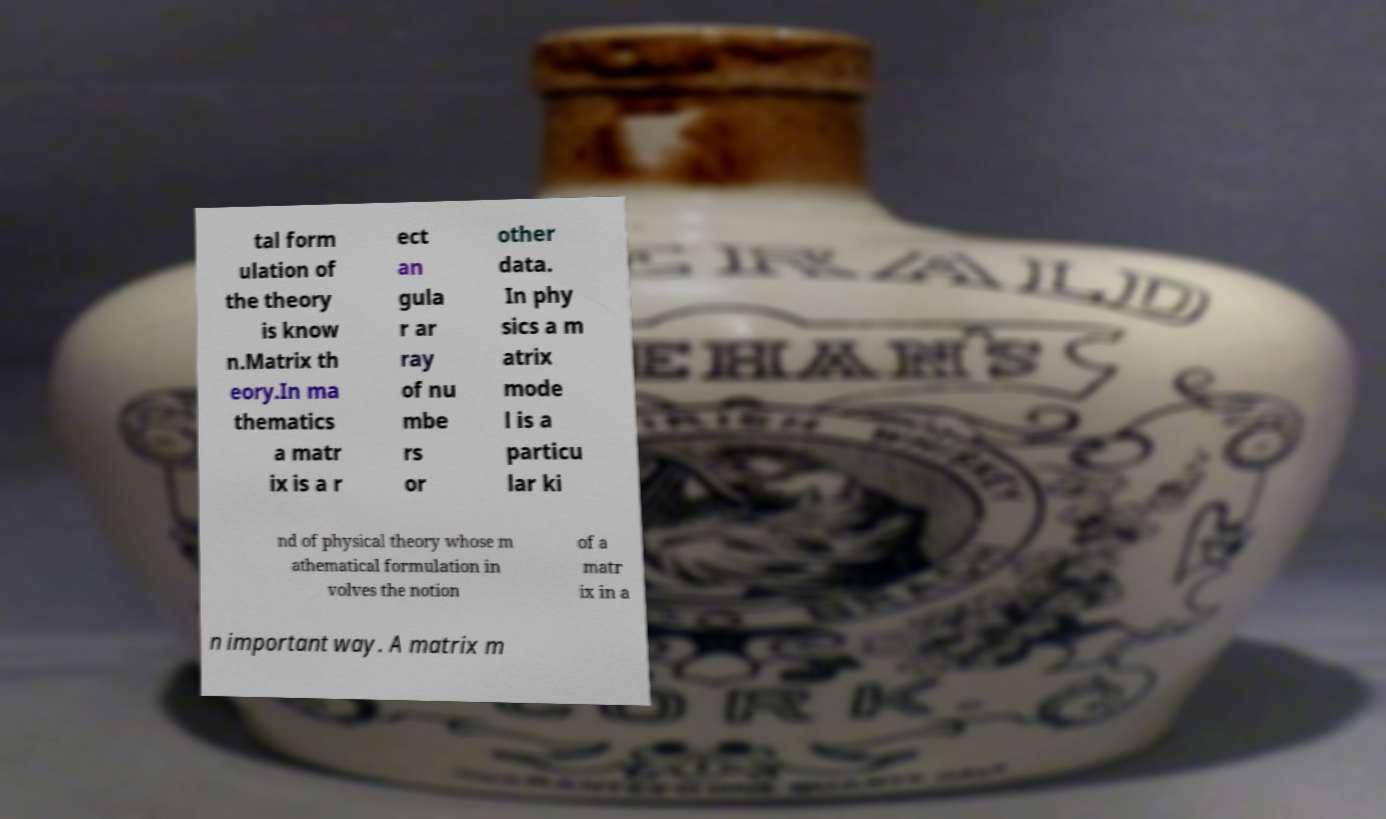Please identify and transcribe the text found in this image. tal form ulation of the theory is know n.Matrix th eory.In ma thematics a matr ix is a r ect an gula r ar ray of nu mbe rs or other data. In phy sics a m atrix mode l is a particu lar ki nd of physical theory whose m athematical formulation in volves the notion of a matr ix in a n important way. A matrix m 